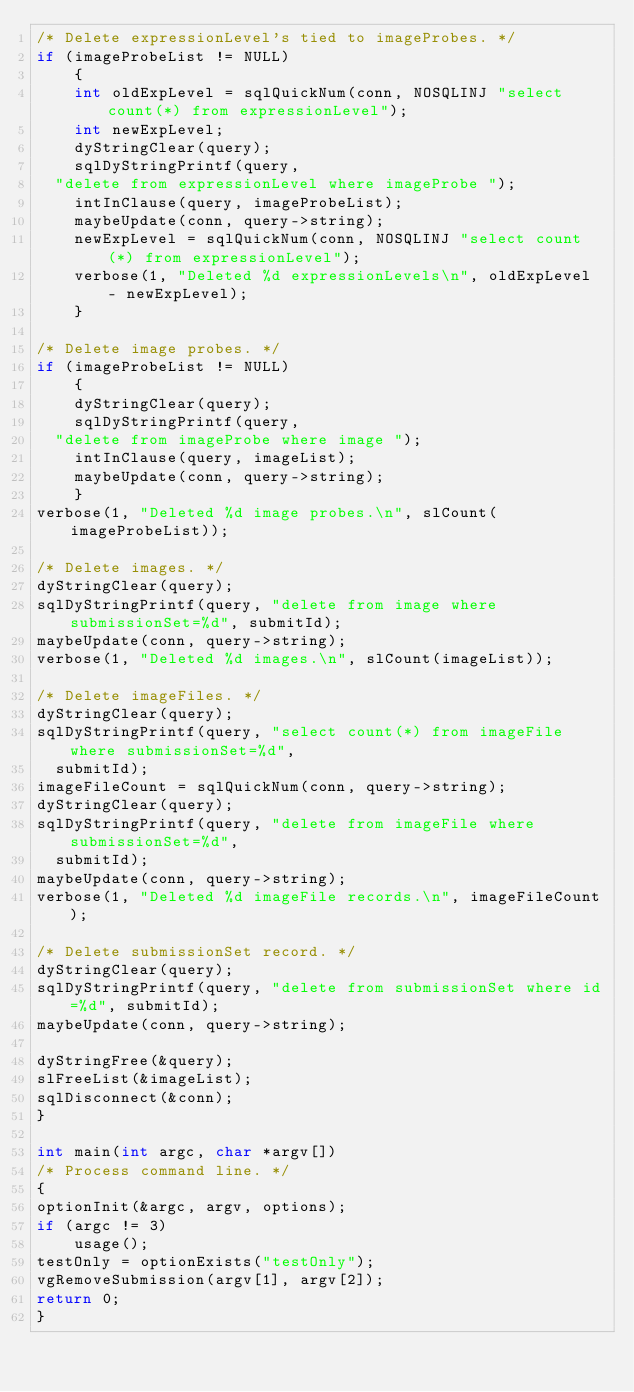Convert code to text. <code><loc_0><loc_0><loc_500><loc_500><_C_>/* Delete expressionLevel's tied to imageProbes. */
if (imageProbeList != NULL)
    {
    int oldExpLevel = sqlQuickNum(conn, NOSQLINJ "select count(*) from expressionLevel");
    int newExpLevel;
    dyStringClear(query);
    sqlDyStringPrintf(query, 
	"delete from expressionLevel where imageProbe ");
    intInClause(query, imageProbeList);
    maybeUpdate(conn, query->string);
    newExpLevel = sqlQuickNum(conn, NOSQLINJ "select count(*) from expressionLevel");
    verbose(1, "Deleted %d expressionLevels\n", oldExpLevel - newExpLevel);
    }

/* Delete image probes. */
if (imageProbeList != NULL)
    {
    dyStringClear(query);
    sqlDyStringPrintf(query, 
	"delete from imageProbe where image ");
    intInClause(query, imageList);
    maybeUpdate(conn, query->string);
    }
verbose(1, "Deleted %d image probes.\n", slCount(imageProbeList));

/* Delete images. */
dyStringClear(query);
sqlDyStringPrintf(query, "delete from image where submissionSet=%d", submitId);
maybeUpdate(conn, query->string);
verbose(1, "Deleted %d images.\n", slCount(imageList));

/* Delete imageFiles. */
dyStringClear(query);
sqlDyStringPrintf(query, "select count(*) from imageFile where submissionSet=%d", 
	submitId);
imageFileCount = sqlQuickNum(conn, query->string);
dyStringClear(query);
sqlDyStringPrintf(query, "delete from imageFile where submissionSet=%d", 
	submitId);
maybeUpdate(conn, query->string);
verbose(1, "Deleted %d imageFile records.\n", imageFileCount);

/* Delete submissionSet record. */
dyStringClear(query);
sqlDyStringPrintf(query, "delete from submissionSet where id=%d", submitId);
maybeUpdate(conn, query->string);

dyStringFree(&query);
slFreeList(&imageList);
sqlDisconnect(&conn);
}

int main(int argc, char *argv[])
/* Process command line. */
{
optionInit(&argc, argv, options);
if (argc != 3)
    usage();
testOnly = optionExists("testOnly");
vgRemoveSubmission(argv[1], argv[2]);
return 0;
}
</code> 